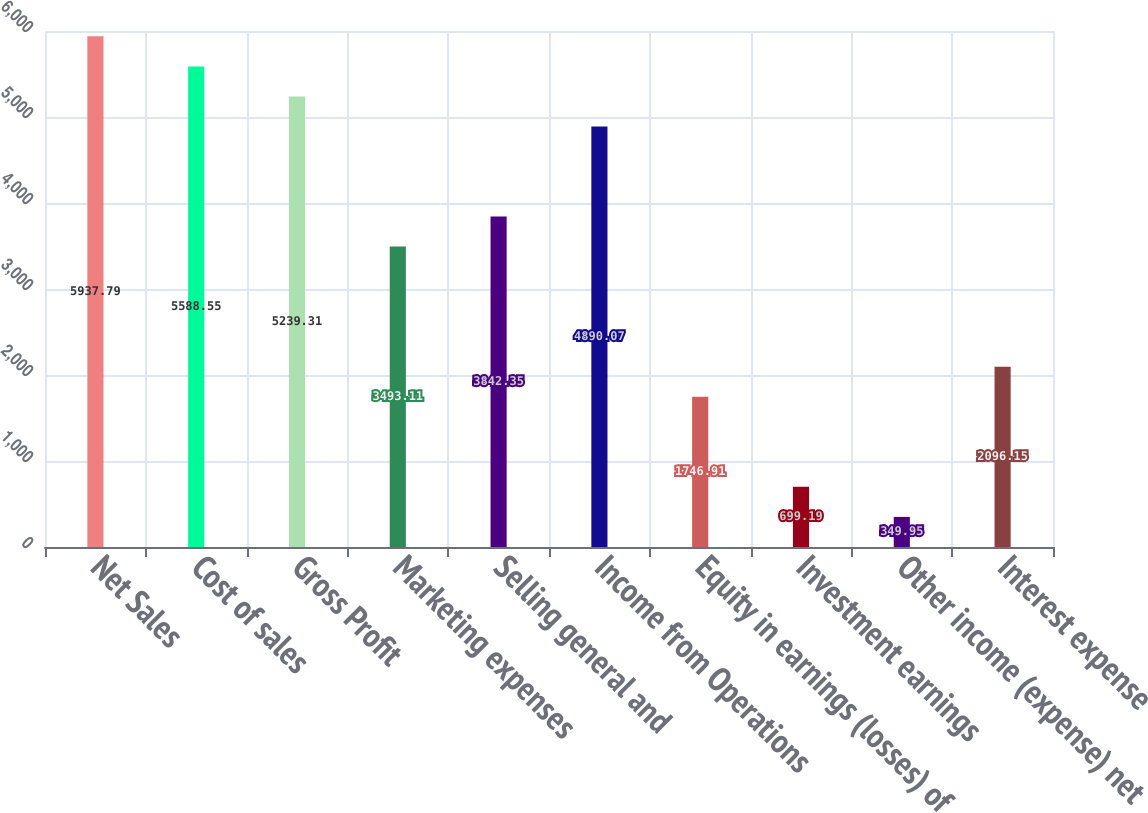Convert chart. <chart><loc_0><loc_0><loc_500><loc_500><bar_chart><fcel>Net Sales<fcel>Cost of sales<fcel>Gross Profit<fcel>Marketing expenses<fcel>Selling general and<fcel>Income from Operations<fcel>Equity in earnings (losses) of<fcel>Investment earnings<fcel>Other income (expense) net<fcel>Interest expense<nl><fcel>5937.79<fcel>5588.55<fcel>5239.31<fcel>3493.11<fcel>3842.35<fcel>4890.07<fcel>1746.91<fcel>699.19<fcel>349.95<fcel>2096.15<nl></chart> 